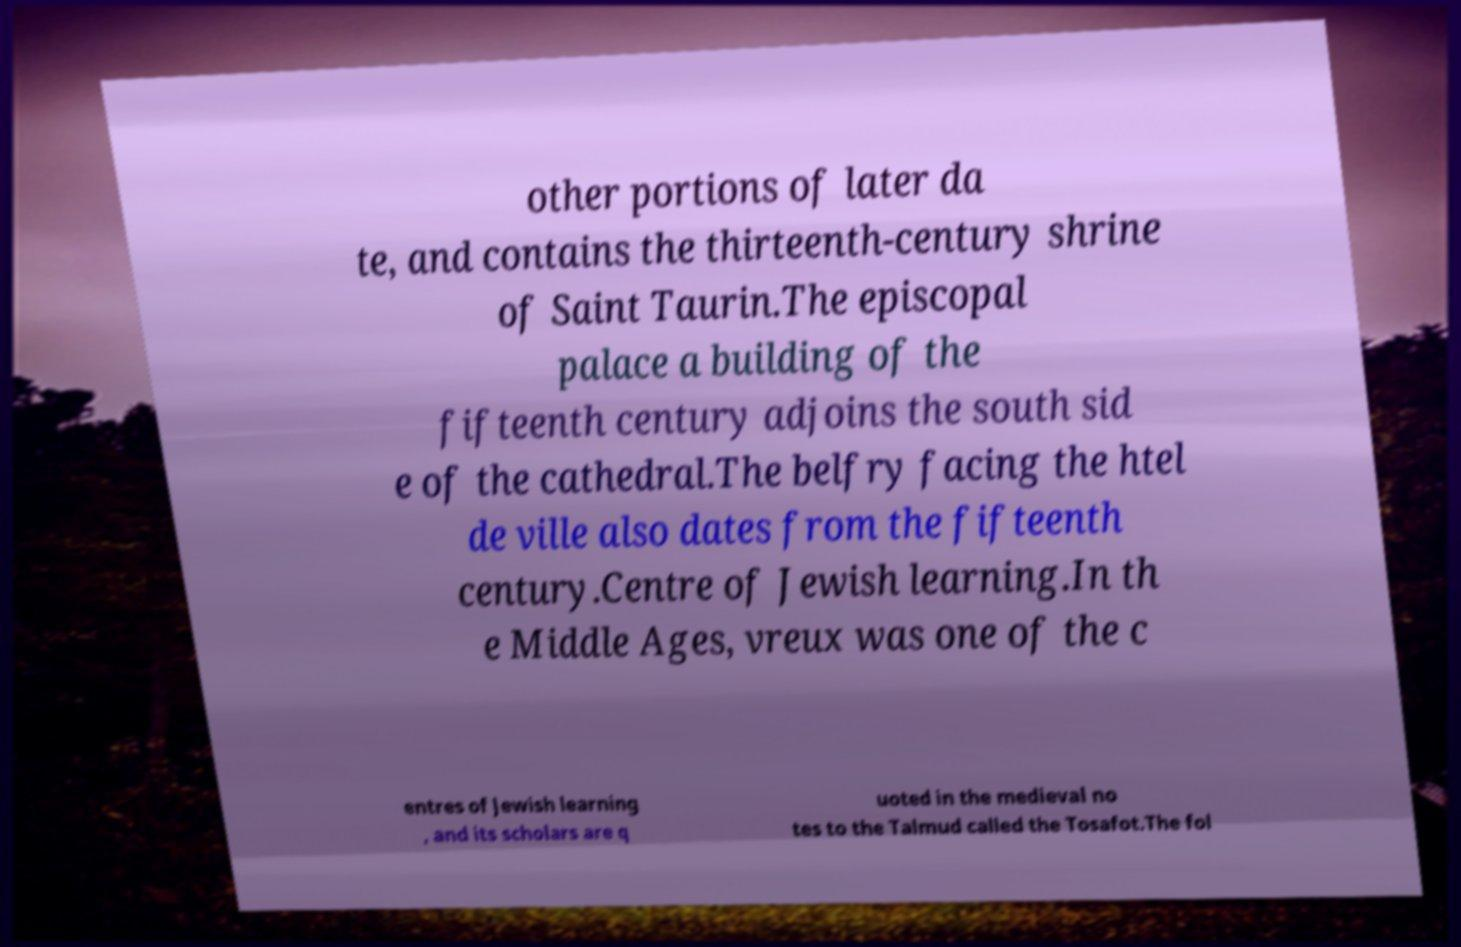Could you assist in decoding the text presented in this image and type it out clearly? other portions of later da te, and contains the thirteenth-century shrine of Saint Taurin.The episcopal palace a building of the fifteenth century adjoins the south sid e of the cathedral.The belfry facing the htel de ville also dates from the fifteenth century.Centre of Jewish learning.In th e Middle Ages, vreux was one of the c entres of Jewish learning , and its scholars are q uoted in the medieval no tes to the Talmud called the Tosafot.The fol 